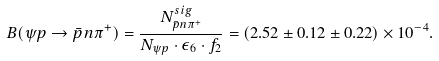<formula> <loc_0><loc_0><loc_500><loc_500>B ( \psi p \to \bar { p } n \pi ^ { + } ) = \frac { N ^ { s i g } _ { \bar { p } n \pi ^ { + } } } { N _ { \psi p } \cdot \epsilon _ { 6 } \cdot f _ { 2 } } = ( 2 . 5 2 \pm 0 . 1 2 \pm 0 . 2 2 ) \times 1 0 ^ { - 4 } .</formula> 